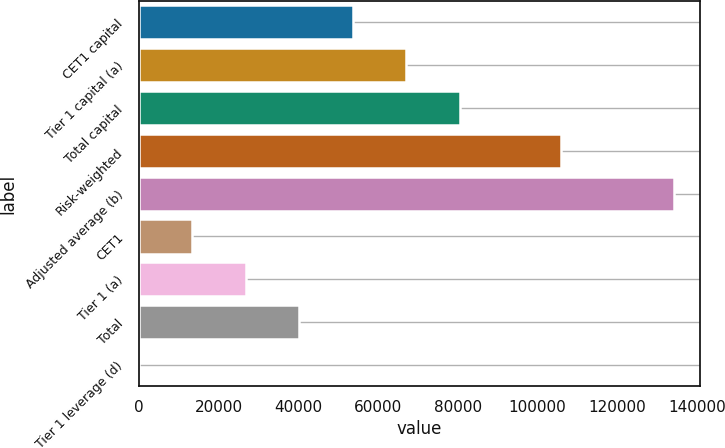Convert chart. <chart><loc_0><loc_0><loc_500><loc_500><bar_chart><fcel>CET1 capital<fcel>Tier 1 capital (a)<fcel>Total capital<fcel>Risk-weighted<fcel>Adjusted average (b)<fcel>CET1<fcel>Tier 1 (a)<fcel>Total<fcel>Tier 1 leverage (d)<nl><fcel>53667.7<fcel>67081.8<fcel>80495.8<fcel>105807<fcel>134152<fcel>13425.5<fcel>26839.6<fcel>40253.7<fcel>11.5<nl></chart> 